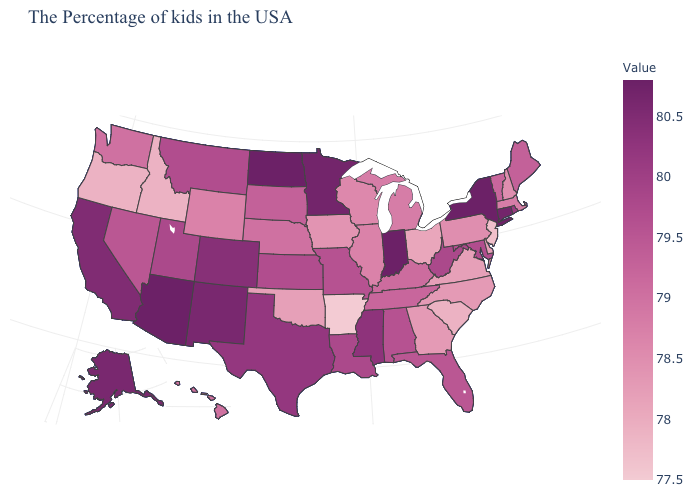Does Arkansas have the lowest value in the USA?
Write a very short answer. Yes. Among the states that border New York , which have the highest value?
Write a very short answer. Connecticut. Which states hav the highest value in the South?
Keep it brief. Mississippi. Does Texas have the highest value in the USA?
Short answer required. No. Is the legend a continuous bar?
Short answer required. Yes. 